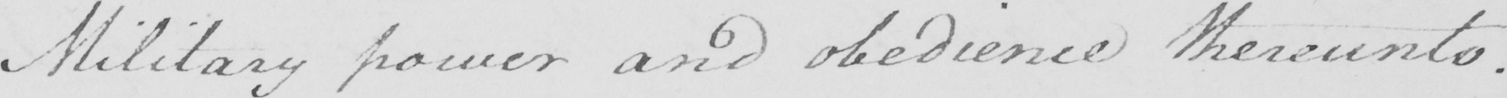Can you read and transcribe this handwriting? Military power and obedience thereunto . 